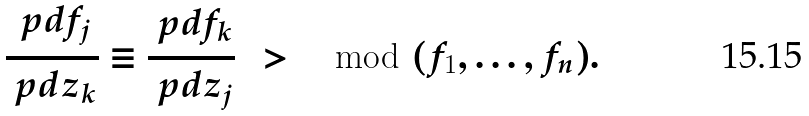<formula> <loc_0><loc_0><loc_500><loc_500>\frac { \ p d f _ { j } } { \ p d z _ { k } } \equiv \frac { \ p d f _ { k } } { \ p d z _ { j } } \, \ > \mod ( f _ { 1 } , \dots , f _ { n } ) .</formula> 